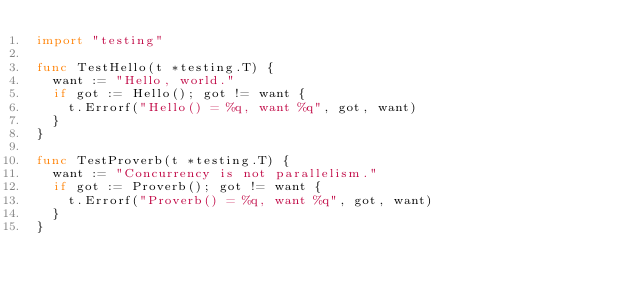<code> <loc_0><loc_0><loc_500><loc_500><_Go_>import "testing"

func TestHello(t *testing.T) {
	want := "Hello, world."
	if got := Hello(); got != want {
		t.Errorf("Hello() = %q, want %q", got, want)
	}
}

func TestProverb(t *testing.T) {
	want := "Concurrency is not parallelism."
	if got := Proverb(); got != want {
		t.Errorf("Proverb() = %q, want %q", got, want)
	}
}
</code> 